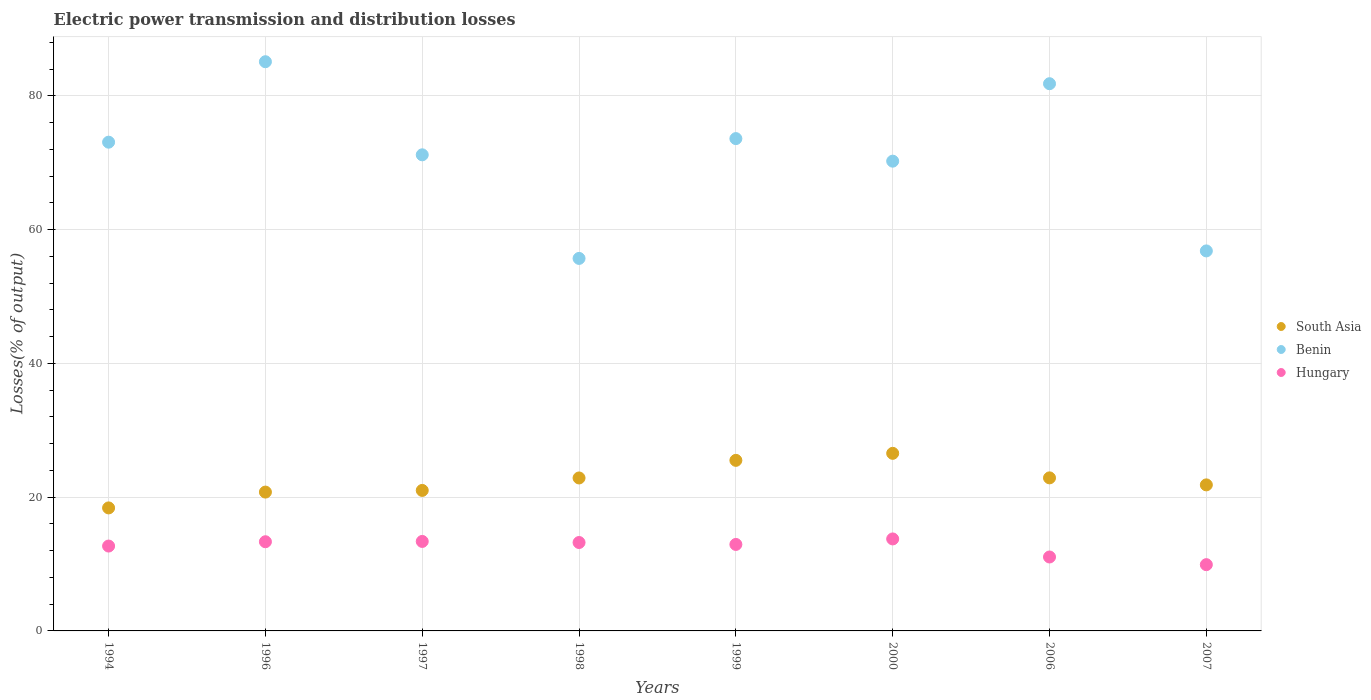How many different coloured dotlines are there?
Make the answer very short. 3. Is the number of dotlines equal to the number of legend labels?
Make the answer very short. Yes. What is the electric power transmission and distribution losses in Benin in 2006?
Give a very brief answer. 81.82. Across all years, what is the maximum electric power transmission and distribution losses in Hungary?
Your response must be concise. 13.75. Across all years, what is the minimum electric power transmission and distribution losses in Hungary?
Your answer should be very brief. 9.91. What is the total electric power transmission and distribution losses in Hungary in the graph?
Offer a very short reply. 100.27. What is the difference between the electric power transmission and distribution losses in South Asia in 1996 and that in 2000?
Provide a succinct answer. -5.79. What is the difference between the electric power transmission and distribution losses in South Asia in 1998 and the electric power transmission and distribution losses in Hungary in 1997?
Make the answer very short. 9.49. What is the average electric power transmission and distribution losses in Benin per year?
Offer a terse response. 70.94. In the year 2007, what is the difference between the electric power transmission and distribution losses in Benin and electric power transmission and distribution losses in South Asia?
Your response must be concise. 34.98. In how many years, is the electric power transmission and distribution losses in Hungary greater than 76 %?
Offer a terse response. 0. What is the ratio of the electric power transmission and distribution losses in South Asia in 1996 to that in 1999?
Give a very brief answer. 0.81. What is the difference between the highest and the second highest electric power transmission and distribution losses in Hungary?
Give a very brief answer. 0.37. What is the difference between the highest and the lowest electric power transmission and distribution losses in South Asia?
Ensure brevity in your answer.  8.16. Is the sum of the electric power transmission and distribution losses in South Asia in 2006 and 2007 greater than the maximum electric power transmission and distribution losses in Hungary across all years?
Make the answer very short. Yes. Is it the case that in every year, the sum of the electric power transmission and distribution losses in Hungary and electric power transmission and distribution losses in South Asia  is greater than the electric power transmission and distribution losses in Benin?
Provide a succinct answer. No. Is the electric power transmission and distribution losses in South Asia strictly greater than the electric power transmission and distribution losses in Hungary over the years?
Provide a succinct answer. Yes. Is the electric power transmission and distribution losses in Benin strictly less than the electric power transmission and distribution losses in South Asia over the years?
Your answer should be compact. No. How many dotlines are there?
Provide a short and direct response. 3. How many years are there in the graph?
Provide a short and direct response. 8. What is the difference between two consecutive major ticks on the Y-axis?
Make the answer very short. 20. Are the values on the major ticks of Y-axis written in scientific E-notation?
Ensure brevity in your answer.  No. Does the graph contain grids?
Offer a terse response. Yes. How are the legend labels stacked?
Your response must be concise. Vertical. What is the title of the graph?
Your answer should be very brief. Electric power transmission and distribution losses. Does "Guam" appear as one of the legend labels in the graph?
Offer a very short reply. No. What is the label or title of the X-axis?
Offer a very short reply. Years. What is the label or title of the Y-axis?
Provide a short and direct response. Losses(% of output). What is the Losses(% of output) of South Asia in 1994?
Your answer should be very brief. 18.39. What is the Losses(% of output) of Benin in 1994?
Provide a short and direct response. 73.08. What is the Losses(% of output) of Hungary in 1994?
Keep it short and to the point. 12.69. What is the Losses(% of output) of South Asia in 1996?
Your response must be concise. 20.76. What is the Losses(% of output) of Benin in 1996?
Make the answer very short. 85.11. What is the Losses(% of output) of Hungary in 1996?
Your response must be concise. 13.33. What is the Losses(% of output) in South Asia in 1997?
Your response must be concise. 21.01. What is the Losses(% of output) in Benin in 1997?
Provide a succinct answer. 71.19. What is the Losses(% of output) in Hungary in 1997?
Provide a short and direct response. 13.38. What is the Losses(% of output) in South Asia in 1998?
Give a very brief answer. 22.87. What is the Losses(% of output) of Benin in 1998?
Your answer should be compact. 55.7. What is the Losses(% of output) in Hungary in 1998?
Your answer should be compact. 13.22. What is the Losses(% of output) of South Asia in 1999?
Provide a short and direct response. 25.5. What is the Losses(% of output) of Benin in 1999?
Make the answer very short. 73.61. What is the Losses(% of output) in Hungary in 1999?
Provide a short and direct response. 12.93. What is the Losses(% of output) of South Asia in 2000?
Your response must be concise. 26.55. What is the Losses(% of output) in Benin in 2000?
Give a very brief answer. 70.24. What is the Losses(% of output) in Hungary in 2000?
Give a very brief answer. 13.75. What is the Losses(% of output) in South Asia in 2006?
Offer a very short reply. 22.88. What is the Losses(% of output) of Benin in 2006?
Your answer should be very brief. 81.82. What is the Losses(% of output) of Hungary in 2006?
Provide a succinct answer. 11.05. What is the Losses(% of output) of South Asia in 2007?
Ensure brevity in your answer.  21.84. What is the Losses(% of output) of Benin in 2007?
Offer a very short reply. 56.82. What is the Losses(% of output) of Hungary in 2007?
Ensure brevity in your answer.  9.91. Across all years, what is the maximum Losses(% of output) of South Asia?
Give a very brief answer. 26.55. Across all years, what is the maximum Losses(% of output) of Benin?
Give a very brief answer. 85.11. Across all years, what is the maximum Losses(% of output) in Hungary?
Provide a succinct answer. 13.75. Across all years, what is the minimum Losses(% of output) of South Asia?
Give a very brief answer. 18.39. Across all years, what is the minimum Losses(% of output) of Benin?
Provide a short and direct response. 55.7. Across all years, what is the minimum Losses(% of output) of Hungary?
Ensure brevity in your answer.  9.91. What is the total Losses(% of output) in South Asia in the graph?
Ensure brevity in your answer.  179.81. What is the total Losses(% of output) of Benin in the graph?
Ensure brevity in your answer.  567.55. What is the total Losses(% of output) in Hungary in the graph?
Provide a succinct answer. 100.27. What is the difference between the Losses(% of output) in South Asia in 1994 and that in 1996?
Your answer should be very brief. -2.37. What is the difference between the Losses(% of output) in Benin in 1994 and that in 1996?
Provide a short and direct response. -12.03. What is the difference between the Losses(% of output) in Hungary in 1994 and that in 1996?
Your answer should be compact. -0.64. What is the difference between the Losses(% of output) of South Asia in 1994 and that in 1997?
Your answer should be compact. -2.62. What is the difference between the Losses(% of output) in Benin in 1994 and that in 1997?
Your answer should be very brief. 1.89. What is the difference between the Losses(% of output) of Hungary in 1994 and that in 1997?
Make the answer very short. -0.69. What is the difference between the Losses(% of output) in South Asia in 1994 and that in 1998?
Give a very brief answer. -4.48. What is the difference between the Losses(% of output) of Benin in 1994 and that in 1998?
Your answer should be compact. 17.38. What is the difference between the Losses(% of output) of Hungary in 1994 and that in 1998?
Give a very brief answer. -0.53. What is the difference between the Losses(% of output) of South Asia in 1994 and that in 1999?
Your answer should be very brief. -7.11. What is the difference between the Losses(% of output) in Benin in 1994 and that in 1999?
Give a very brief answer. -0.53. What is the difference between the Losses(% of output) in Hungary in 1994 and that in 1999?
Your answer should be very brief. -0.24. What is the difference between the Losses(% of output) of South Asia in 1994 and that in 2000?
Ensure brevity in your answer.  -8.16. What is the difference between the Losses(% of output) in Benin in 1994 and that in 2000?
Your answer should be very brief. 2.84. What is the difference between the Losses(% of output) of Hungary in 1994 and that in 2000?
Ensure brevity in your answer.  -1.06. What is the difference between the Losses(% of output) of South Asia in 1994 and that in 2006?
Your response must be concise. -4.49. What is the difference between the Losses(% of output) of Benin in 1994 and that in 2006?
Provide a short and direct response. -8.74. What is the difference between the Losses(% of output) of Hungary in 1994 and that in 2006?
Ensure brevity in your answer.  1.64. What is the difference between the Losses(% of output) in South Asia in 1994 and that in 2007?
Offer a terse response. -3.44. What is the difference between the Losses(% of output) in Benin in 1994 and that in 2007?
Provide a succinct answer. 16.26. What is the difference between the Losses(% of output) in Hungary in 1994 and that in 2007?
Your answer should be compact. 2.78. What is the difference between the Losses(% of output) in South Asia in 1996 and that in 1997?
Offer a terse response. -0.25. What is the difference between the Losses(% of output) in Benin in 1996 and that in 1997?
Provide a succinct answer. 13.92. What is the difference between the Losses(% of output) in Hungary in 1996 and that in 1997?
Make the answer very short. -0.05. What is the difference between the Losses(% of output) of South Asia in 1996 and that in 1998?
Your answer should be compact. -2.11. What is the difference between the Losses(% of output) of Benin in 1996 and that in 1998?
Your response must be concise. 29.41. What is the difference between the Losses(% of output) of Hungary in 1996 and that in 1998?
Provide a succinct answer. 0.12. What is the difference between the Losses(% of output) of South Asia in 1996 and that in 1999?
Your response must be concise. -4.74. What is the difference between the Losses(% of output) in Benin in 1996 and that in 1999?
Offer a terse response. 11.5. What is the difference between the Losses(% of output) in Hungary in 1996 and that in 1999?
Keep it short and to the point. 0.4. What is the difference between the Losses(% of output) of South Asia in 1996 and that in 2000?
Ensure brevity in your answer.  -5.79. What is the difference between the Losses(% of output) in Benin in 1996 and that in 2000?
Keep it short and to the point. 14.87. What is the difference between the Losses(% of output) in Hungary in 1996 and that in 2000?
Provide a short and direct response. -0.42. What is the difference between the Losses(% of output) of South Asia in 1996 and that in 2006?
Your answer should be compact. -2.12. What is the difference between the Losses(% of output) in Benin in 1996 and that in 2006?
Ensure brevity in your answer.  3.29. What is the difference between the Losses(% of output) in Hungary in 1996 and that in 2006?
Offer a terse response. 2.28. What is the difference between the Losses(% of output) of South Asia in 1996 and that in 2007?
Offer a very short reply. -1.08. What is the difference between the Losses(% of output) of Benin in 1996 and that in 2007?
Make the answer very short. 28.29. What is the difference between the Losses(% of output) of Hungary in 1996 and that in 2007?
Ensure brevity in your answer.  3.43. What is the difference between the Losses(% of output) in South Asia in 1997 and that in 1998?
Ensure brevity in your answer.  -1.86. What is the difference between the Losses(% of output) of Benin in 1997 and that in 1998?
Offer a very short reply. 15.49. What is the difference between the Losses(% of output) of Hungary in 1997 and that in 1998?
Provide a succinct answer. 0.16. What is the difference between the Losses(% of output) of South Asia in 1997 and that in 1999?
Provide a short and direct response. -4.5. What is the difference between the Losses(% of output) of Benin in 1997 and that in 1999?
Give a very brief answer. -2.42. What is the difference between the Losses(% of output) of Hungary in 1997 and that in 1999?
Provide a succinct answer. 0.45. What is the difference between the Losses(% of output) in South Asia in 1997 and that in 2000?
Ensure brevity in your answer.  -5.54. What is the difference between the Losses(% of output) in Benin in 1997 and that in 2000?
Ensure brevity in your answer.  0.95. What is the difference between the Losses(% of output) of Hungary in 1997 and that in 2000?
Make the answer very short. -0.37. What is the difference between the Losses(% of output) of South Asia in 1997 and that in 2006?
Your answer should be very brief. -1.88. What is the difference between the Losses(% of output) of Benin in 1997 and that in 2006?
Provide a succinct answer. -10.63. What is the difference between the Losses(% of output) in Hungary in 1997 and that in 2006?
Give a very brief answer. 2.33. What is the difference between the Losses(% of output) in South Asia in 1997 and that in 2007?
Provide a succinct answer. -0.83. What is the difference between the Losses(% of output) of Benin in 1997 and that in 2007?
Your answer should be very brief. 14.37. What is the difference between the Losses(% of output) of Hungary in 1997 and that in 2007?
Offer a very short reply. 3.47. What is the difference between the Losses(% of output) of South Asia in 1998 and that in 1999?
Provide a short and direct response. -2.63. What is the difference between the Losses(% of output) of Benin in 1998 and that in 1999?
Offer a very short reply. -17.91. What is the difference between the Losses(% of output) in Hungary in 1998 and that in 1999?
Provide a short and direct response. 0.29. What is the difference between the Losses(% of output) of South Asia in 1998 and that in 2000?
Provide a succinct answer. -3.68. What is the difference between the Losses(% of output) of Benin in 1998 and that in 2000?
Your response must be concise. -14.54. What is the difference between the Losses(% of output) in Hungary in 1998 and that in 2000?
Your answer should be compact. -0.53. What is the difference between the Losses(% of output) in South Asia in 1998 and that in 2006?
Offer a very short reply. -0.01. What is the difference between the Losses(% of output) in Benin in 1998 and that in 2006?
Offer a very short reply. -26.12. What is the difference between the Losses(% of output) of Hungary in 1998 and that in 2006?
Make the answer very short. 2.16. What is the difference between the Losses(% of output) in South Asia in 1998 and that in 2007?
Your answer should be compact. 1.04. What is the difference between the Losses(% of output) in Benin in 1998 and that in 2007?
Your response must be concise. -1.12. What is the difference between the Losses(% of output) of Hungary in 1998 and that in 2007?
Give a very brief answer. 3.31. What is the difference between the Losses(% of output) in South Asia in 1999 and that in 2000?
Your answer should be compact. -1.05. What is the difference between the Losses(% of output) in Benin in 1999 and that in 2000?
Ensure brevity in your answer.  3.37. What is the difference between the Losses(% of output) in Hungary in 1999 and that in 2000?
Keep it short and to the point. -0.82. What is the difference between the Losses(% of output) in South Asia in 1999 and that in 2006?
Provide a succinct answer. 2.62. What is the difference between the Losses(% of output) of Benin in 1999 and that in 2006?
Provide a short and direct response. -8.21. What is the difference between the Losses(% of output) of Hungary in 1999 and that in 2006?
Offer a terse response. 1.88. What is the difference between the Losses(% of output) of South Asia in 1999 and that in 2007?
Your response must be concise. 3.67. What is the difference between the Losses(% of output) of Benin in 1999 and that in 2007?
Make the answer very short. 16.79. What is the difference between the Losses(% of output) of Hungary in 1999 and that in 2007?
Keep it short and to the point. 3.02. What is the difference between the Losses(% of output) of South Asia in 2000 and that in 2006?
Your response must be concise. 3.67. What is the difference between the Losses(% of output) in Benin in 2000 and that in 2006?
Offer a terse response. -11.58. What is the difference between the Losses(% of output) of Hungary in 2000 and that in 2006?
Offer a very short reply. 2.7. What is the difference between the Losses(% of output) in South Asia in 2000 and that in 2007?
Give a very brief answer. 4.72. What is the difference between the Losses(% of output) of Benin in 2000 and that in 2007?
Ensure brevity in your answer.  13.42. What is the difference between the Losses(% of output) in Hungary in 2000 and that in 2007?
Offer a terse response. 3.85. What is the difference between the Losses(% of output) in South Asia in 2006 and that in 2007?
Keep it short and to the point. 1.05. What is the difference between the Losses(% of output) of Hungary in 2006 and that in 2007?
Make the answer very short. 1.15. What is the difference between the Losses(% of output) in South Asia in 1994 and the Losses(% of output) in Benin in 1996?
Provide a succinct answer. -66.71. What is the difference between the Losses(% of output) in South Asia in 1994 and the Losses(% of output) in Hungary in 1996?
Offer a very short reply. 5.06. What is the difference between the Losses(% of output) of Benin in 1994 and the Losses(% of output) of Hungary in 1996?
Offer a terse response. 59.74. What is the difference between the Losses(% of output) in South Asia in 1994 and the Losses(% of output) in Benin in 1997?
Provide a short and direct response. -52.79. What is the difference between the Losses(% of output) in South Asia in 1994 and the Losses(% of output) in Hungary in 1997?
Ensure brevity in your answer.  5.01. What is the difference between the Losses(% of output) of Benin in 1994 and the Losses(% of output) of Hungary in 1997?
Make the answer very short. 59.7. What is the difference between the Losses(% of output) of South Asia in 1994 and the Losses(% of output) of Benin in 1998?
Ensure brevity in your answer.  -37.3. What is the difference between the Losses(% of output) in South Asia in 1994 and the Losses(% of output) in Hungary in 1998?
Your answer should be very brief. 5.17. What is the difference between the Losses(% of output) in Benin in 1994 and the Losses(% of output) in Hungary in 1998?
Offer a terse response. 59.86. What is the difference between the Losses(% of output) of South Asia in 1994 and the Losses(% of output) of Benin in 1999?
Provide a short and direct response. -55.22. What is the difference between the Losses(% of output) in South Asia in 1994 and the Losses(% of output) in Hungary in 1999?
Your response must be concise. 5.46. What is the difference between the Losses(% of output) of Benin in 1994 and the Losses(% of output) of Hungary in 1999?
Your response must be concise. 60.15. What is the difference between the Losses(% of output) in South Asia in 1994 and the Losses(% of output) in Benin in 2000?
Offer a terse response. -51.85. What is the difference between the Losses(% of output) of South Asia in 1994 and the Losses(% of output) of Hungary in 2000?
Provide a short and direct response. 4.64. What is the difference between the Losses(% of output) of Benin in 1994 and the Losses(% of output) of Hungary in 2000?
Provide a succinct answer. 59.32. What is the difference between the Losses(% of output) in South Asia in 1994 and the Losses(% of output) in Benin in 2006?
Keep it short and to the point. -63.43. What is the difference between the Losses(% of output) in South Asia in 1994 and the Losses(% of output) in Hungary in 2006?
Provide a short and direct response. 7.34. What is the difference between the Losses(% of output) in Benin in 1994 and the Losses(% of output) in Hungary in 2006?
Your answer should be very brief. 62.02. What is the difference between the Losses(% of output) of South Asia in 1994 and the Losses(% of output) of Benin in 2007?
Ensure brevity in your answer.  -38.43. What is the difference between the Losses(% of output) of South Asia in 1994 and the Losses(% of output) of Hungary in 2007?
Your answer should be very brief. 8.48. What is the difference between the Losses(% of output) in Benin in 1994 and the Losses(% of output) in Hungary in 2007?
Provide a short and direct response. 63.17. What is the difference between the Losses(% of output) in South Asia in 1996 and the Losses(% of output) in Benin in 1997?
Give a very brief answer. -50.43. What is the difference between the Losses(% of output) of South Asia in 1996 and the Losses(% of output) of Hungary in 1997?
Offer a terse response. 7.38. What is the difference between the Losses(% of output) in Benin in 1996 and the Losses(% of output) in Hungary in 1997?
Offer a very short reply. 71.73. What is the difference between the Losses(% of output) in South Asia in 1996 and the Losses(% of output) in Benin in 1998?
Your answer should be compact. -34.94. What is the difference between the Losses(% of output) of South Asia in 1996 and the Losses(% of output) of Hungary in 1998?
Offer a terse response. 7.54. What is the difference between the Losses(% of output) in Benin in 1996 and the Losses(% of output) in Hungary in 1998?
Ensure brevity in your answer.  71.89. What is the difference between the Losses(% of output) of South Asia in 1996 and the Losses(% of output) of Benin in 1999?
Provide a short and direct response. -52.85. What is the difference between the Losses(% of output) of South Asia in 1996 and the Losses(% of output) of Hungary in 1999?
Offer a very short reply. 7.83. What is the difference between the Losses(% of output) of Benin in 1996 and the Losses(% of output) of Hungary in 1999?
Keep it short and to the point. 72.18. What is the difference between the Losses(% of output) of South Asia in 1996 and the Losses(% of output) of Benin in 2000?
Offer a very short reply. -49.48. What is the difference between the Losses(% of output) of South Asia in 1996 and the Losses(% of output) of Hungary in 2000?
Give a very brief answer. 7.01. What is the difference between the Losses(% of output) in Benin in 1996 and the Losses(% of output) in Hungary in 2000?
Offer a very short reply. 71.35. What is the difference between the Losses(% of output) in South Asia in 1996 and the Losses(% of output) in Benin in 2006?
Ensure brevity in your answer.  -61.06. What is the difference between the Losses(% of output) in South Asia in 1996 and the Losses(% of output) in Hungary in 2006?
Offer a terse response. 9.71. What is the difference between the Losses(% of output) in Benin in 1996 and the Losses(% of output) in Hungary in 2006?
Make the answer very short. 74.05. What is the difference between the Losses(% of output) of South Asia in 1996 and the Losses(% of output) of Benin in 2007?
Your response must be concise. -36.06. What is the difference between the Losses(% of output) of South Asia in 1996 and the Losses(% of output) of Hungary in 2007?
Make the answer very short. 10.85. What is the difference between the Losses(% of output) of Benin in 1996 and the Losses(% of output) of Hungary in 2007?
Offer a very short reply. 75.2. What is the difference between the Losses(% of output) of South Asia in 1997 and the Losses(% of output) of Benin in 1998?
Give a very brief answer. -34.69. What is the difference between the Losses(% of output) in South Asia in 1997 and the Losses(% of output) in Hungary in 1998?
Provide a short and direct response. 7.79. What is the difference between the Losses(% of output) of Benin in 1997 and the Losses(% of output) of Hungary in 1998?
Ensure brevity in your answer.  57.97. What is the difference between the Losses(% of output) of South Asia in 1997 and the Losses(% of output) of Benin in 1999?
Offer a very short reply. -52.6. What is the difference between the Losses(% of output) in South Asia in 1997 and the Losses(% of output) in Hungary in 1999?
Give a very brief answer. 8.08. What is the difference between the Losses(% of output) in Benin in 1997 and the Losses(% of output) in Hungary in 1999?
Your response must be concise. 58.26. What is the difference between the Losses(% of output) of South Asia in 1997 and the Losses(% of output) of Benin in 2000?
Ensure brevity in your answer.  -49.23. What is the difference between the Losses(% of output) of South Asia in 1997 and the Losses(% of output) of Hungary in 2000?
Provide a short and direct response. 7.25. What is the difference between the Losses(% of output) in Benin in 1997 and the Losses(% of output) in Hungary in 2000?
Keep it short and to the point. 57.43. What is the difference between the Losses(% of output) of South Asia in 1997 and the Losses(% of output) of Benin in 2006?
Provide a succinct answer. -60.81. What is the difference between the Losses(% of output) in South Asia in 1997 and the Losses(% of output) in Hungary in 2006?
Your answer should be compact. 9.95. What is the difference between the Losses(% of output) of Benin in 1997 and the Losses(% of output) of Hungary in 2006?
Make the answer very short. 60.13. What is the difference between the Losses(% of output) of South Asia in 1997 and the Losses(% of output) of Benin in 2007?
Offer a terse response. -35.81. What is the difference between the Losses(% of output) in South Asia in 1997 and the Losses(% of output) in Hungary in 2007?
Your answer should be very brief. 11.1. What is the difference between the Losses(% of output) of Benin in 1997 and the Losses(% of output) of Hungary in 2007?
Your answer should be compact. 61.28. What is the difference between the Losses(% of output) in South Asia in 1998 and the Losses(% of output) in Benin in 1999?
Offer a very short reply. -50.74. What is the difference between the Losses(% of output) of South Asia in 1998 and the Losses(% of output) of Hungary in 1999?
Your answer should be compact. 9.94. What is the difference between the Losses(% of output) of Benin in 1998 and the Losses(% of output) of Hungary in 1999?
Your answer should be very brief. 42.77. What is the difference between the Losses(% of output) in South Asia in 1998 and the Losses(% of output) in Benin in 2000?
Ensure brevity in your answer.  -47.37. What is the difference between the Losses(% of output) of South Asia in 1998 and the Losses(% of output) of Hungary in 2000?
Provide a short and direct response. 9.12. What is the difference between the Losses(% of output) of Benin in 1998 and the Losses(% of output) of Hungary in 2000?
Provide a short and direct response. 41.94. What is the difference between the Losses(% of output) in South Asia in 1998 and the Losses(% of output) in Benin in 2006?
Keep it short and to the point. -58.95. What is the difference between the Losses(% of output) of South Asia in 1998 and the Losses(% of output) of Hungary in 2006?
Your answer should be compact. 11.82. What is the difference between the Losses(% of output) in Benin in 1998 and the Losses(% of output) in Hungary in 2006?
Your answer should be compact. 44.64. What is the difference between the Losses(% of output) of South Asia in 1998 and the Losses(% of output) of Benin in 2007?
Your answer should be very brief. -33.95. What is the difference between the Losses(% of output) of South Asia in 1998 and the Losses(% of output) of Hungary in 2007?
Provide a short and direct response. 12.96. What is the difference between the Losses(% of output) in Benin in 1998 and the Losses(% of output) in Hungary in 2007?
Keep it short and to the point. 45.79. What is the difference between the Losses(% of output) in South Asia in 1999 and the Losses(% of output) in Benin in 2000?
Offer a very short reply. -44.74. What is the difference between the Losses(% of output) of South Asia in 1999 and the Losses(% of output) of Hungary in 2000?
Offer a terse response. 11.75. What is the difference between the Losses(% of output) of Benin in 1999 and the Losses(% of output) of Hungary in 2000?
Provide a succinct answer. 59.86. What is the difference between the Losses(% of output) in South Asia in 1999 and the Losses(% of output) in Benin in 2006?
Your response must be concise. -56.32. What is the difference between the Losses(% of output) of South Asia in 1999 and the Losses(% of output) of Hungary in 2006?
Provide a succinct answer. 14.45. What is the difference between the Losses(% of output) of Benin in 1999 and the Losses(% of output) of Hungary in 2006?
Provide a succinct answer. 62.56. What is the difference between the Losses(% of output) in South Asia in 1999 and the Losses(% of output) in Benin in 2007?
Offer a terse response. -31.32. What is the difference between the Losses(% of output) of South Asia in 1999 and the Losses(% of output) of Hungary in 2007?
Your response must be concise. 15.6. What is the difference between the Losses(% of output) in Benin in 1999 and the Losses(% of output) in Hungary in 2007?
Give a very brief answer. 63.7. What is the difference between the Losses(% of output) in South Asia in 2000 and the Losses(% of output) in Benin in 2006?
Your answer should be very brief. -55.27. What is the difference between the Losses(% of output) of South Asia in 2000 and the Losses(% of output) of Hungary in 2006?
Make the answer very short. 15.5. What is the difference between the Losses(% of output) in Benin in 2000 and the Losses(% of output) in Hungary in 2006?
Your response must be concise. 59.18. What is the difference between the Losses(% of output) in South Asia in 2000 and the Losses(% of output) in Benin in 2007?
Make the answer very short. -30.27. What is the difference between the Losses(% of output) of South Asia in 2000 and the Losses(% of output) of Hungary in 2007?
Your answer should be compact. 16.64. What is the difference between the Losses(% of output) in Benin in 2000 and the Losses(% of output) in Hungary in 2007?
Keep it short and to the point. 60.33. What is the difference between the Losses(% of output) in South Asia in 2006 and the Losses(% of output) in Benin in 2007?
Make the answer very short. -33.93. What is the difference between the Losses(% of output) of South Asia in 2006 and the Losses(% of output) of Hungary in 2007?
Your answer should be very brief. 12.98. What is the difference between the Losses(% of output) of Benin in 2006 and the Losses(% of output) of Hungary in 2007?
Offer a terse response. 71.91. What is the average Losses(% of output) of South Asia per year?
Offer a terse response. 22.48. What is the average Losses(% of output) of Benin per year?
Ensure brevity in your answer.  70.94. What is the average Losses(% of output) of Hungary per year?
Your answer should be very brief. 12.53. In the year 1994, what is the difference between the Losses(% of output) of South Asia and Losses(% of output) of Benin?
Provide a succinct answer. -54.68. In the year 1994, what is the difference between the Losses(% of output) of South Asia and Losses(% of output) of Hungary?
Your answer should be very brief. 5.7. In the year 1994, what is the difference between the Losses(% of output) in Benin and Losses(% of output) in Hungary?
Keep it short and to the point. 60.39. In the year 1996, what is the difference between the Losses(% of output) of South Asia and Losses(% of output) of Benin?
Your response must be concise. -64.35. In the year 1996, what is the difference between the Losses(% of output) of South Asia and Losses(% of output) of Hungary?
Your answer should be compact. 7.43. In the year 1996, what is the difference between the Losses(% of output) of Benin and Losses(% of output) of Hungary?
Offer a very short reply. 71.77. In the year 1997, what is the difference between the Losses(% of output) in South Asia and Losses(% of output) in Benin?
Your answer should be compact. -50.18. In the year 1997, what is the difference between the Losses(% of output) in South Asia and Losses(% of output) in Hungary?
Your answer should be compact. 7.63. In the year 1997, what is the difference between the Losses(% of output) of Benin and Losses(% of output) of Hungary?
Your response must be concise. 57.81. In the year 1998, what is the difference between the Losses(% of output) of South Asia and Losses(% of output) of Benin?
Provide a short and direct response. -32.83. In the year 1998, what is the difference between the Losses(% of output) of South Asia and Losses(% of output) of Hungary?
Provide a short and direct response. 9.65. In the year 1998, what is the difference between the Losses(% of output) of Benin and Losses(% of output) of Hungary?
Make the answer very short. 42.48. In the year 1999, what is the difference between the Losses(% of output) in South Asia and Losses(% of output) in Benin?
Make the answer very short. -48.11. In the year 1999, what is the difference between the Losses(% of output) in South Asia and Losses(% of output) in Hungary?
Your answer should be very brief. 12.57. In the year 1999, what is the difference between the Losses(% of output) of Benin and Losses(% of output) of Hungary?
Ensure brevity in your answer.  60.68. In the year 2000, what is the difference between the Losses(% of output) of South Asia and Losses(% of output) of Benin?
Offer a terse response. -43.69. In the year 2000, what is the difference between the Losses(% of output) in South Asia and Losses(% of output) in Hungary?
Your response must be concise. 12.8. In the year 2000, what is the difference between the Losses(% of output) in Benin and Losses(% of output) in Hungary?
Your response must be concise. 56.48. In the year 2006, what is the difference between the Losses(% of output) in South Asia and Losses(% of output) in Benin?
Offer a terse response. -58.93. In the year 2006, what is the difference between the Losses(% of output) in South Asia and Losses(% of output) in Hungary?
Ensure brevity in your answer.  11.83. In the year 2006, what is the difference between the Losses(% of output) in Benin and Losses(% of output) in Hungary?
Your response must be concise. 70.76. In the year 2007, what is the difference between the Losses(% of output) of South Asia and Losses(% of output) of Benin?
Your response must be concise. -34.98. In the year 2007, what is the difference between the Losses(% of output) in South Asia and Losses(% of output) in Hungary?
Your response must be concise. 11.93. In the year 2007, what is the difference between the Losses(% of output) in Benin and Losses(% of output) in Hungary?
Keep it short and to the point. 46.91. What is the ratio of the Losses(% of output) in South Asia in 1994 to that in 1996?
Ensure brevity in your answer.  0.89. What is the ratio of the Losses(% of output) in Benin in 1994 to that in 1996?
Offer a very short reply. 0.86. What is the ratio of the Losses(% of output) in Hungary in 1994 to that in 1996?
Keep it short and to the point. 0.95. What is the ratio of the Losses(% of output) of South Asia in 1994 to that in 1997?
Give a very brief answer. 0.88. What is the ratio of the Losses(% of output) in Benin in 1994 to that in 1997?
Your response must be concise. 1.03. What is the ratio of the Losses(% of output) of Hungary in 1994 to that in 1997?
Your answer should be compact. 0.95. What is the ratio of the Losses(% of output) of South Asia in 1994 to that in 1998?
Offer a very short reply. 0.8. What is the ratio of the Losses(% of output) in Benin in 1994 to that in 1998?
Offer a very short reply. 1.31. What is the ratio of the Losses(% of output) of Hungary in 1994 to that in 1998?
Keep it short and to the point. 0.96. What is the ratio of the Losses(% of output) in South Asia in 1994 to that in 1999?
Keep it short and to the point. 0.72. What is the ratio of the Losses(% of output) of Hungary in 1994 to that in 1999?
Make the answer very short. 0.98. What is the ratio of the Losses(% of output) in South Asia in 1994 to that in 2000?
Keep it short and to the point. 0.69. What is the ratio of the Losses(% of output) in Benin in 1994 to that in 2000?
Give a very brief answer. 1.04. What is the ratio of the Losses(% of output) of Hungary in 1994 to that in 2000?
Offer a very short reply. 0.92. What is the ratio of the Losses(% of output) of South Asia in 1994 to that in 2006?
Offer a terse response. 0.8. What is the ratio of the Losses(% of output) of Benin in 1994 to that in 2006?
Provide a short and direct response. 0.89. What is the ratio of the Losses(% of output) in Hungary in 1994 to that in 2006?
Offer a very short reply. 1.15. What is the ratio of the Losses(% of output) in South Asia in 1994 to that in 2007?
Your answer should be compact. 0.84. What is the ratio of the Losses(% of output) in Benin in 1994 to that in 2007?
Make the answer very short. 1.29. What is the ratio of the Losses(% of output) in Hungary in 1994 to that in 2007?
Give a very brief answer. 1.28. What is the ratio of the Losses(% of output) of South Asia in 1996 to that in 1997?
Offer a very short reply. 0.99. What is the ratio of the Losses(% of output) of Benin in 1996 to that in 1997?
Your answer should be very brief. 1.2. What is the ratio of the Losses(% of output) in South Asia in 1996 to that in 1998?
Provide a succinct answer. 0.91. What is the ratio of the Losses(% of output) in Benin in 1996 to that in 1998?
Offer a very short reply. 1.53. What is the ratio of the Losses(% of output) in Hungary in 1996 to that in 1998?
Give a very brief answer. 1.01. What is the ratio of the Losses(% of output) in South Asia in 1996 to that in 1999?
Make the answer very short. 0.81. What is the ratio of the Losses(% of output) of Benin in 1996 to that in 1999?
Your response must be concise. 1.16. What is the ratio of the Losses(% of output) in Hungary in 1996 to that in 1999?
Provide a short and direct response. 1.03. What is the ratio of the Losses(% of output) of South Asia in 1996 to that in 2000?
Ensure brevity in your answer.  0.78. What is the ratio of the Losses(% of output) in Benin in 1996 to that in 2000?
Keep it short and to the point. 1.21. What is the ratio of the Losses(% of output) of Hungary in 1996 to that in 2000?
Ensure brevity in your answer.  0.97. What is the ratio of the Losses(% of output) of South Asia in 1996 to that in 2006?
Provide a short and direct response. 0.91. What is the ratio of the Losses(% of output) of Benin in 1996 to that in 2006?
Keep it short and to the point. 1.04. What is the ratio of the Losses(% of output) of Hungary in 1996 to that in 2006?
Your answer should be very brief. 1.21. What is the ratio of the Losses(% of output) of South Asia in 1996 to that in 2007?
Your answer should be compact. 0.95. What is the ratio of the Losses(% of output) in Benin in 1996 to that in 2007?
Ensure brevity in your answer.  1.5. What is the ratio of the Losses(% of output) in Hungary in 1996 to that in 2007?
Provide a succinct answer. 1.35. What is the ratio of the Losses(% of output) in South Asia in 1997 to that in 1998?
Make the answer very short. 0.92. What is the ratio of the Losses(% of output) in Benin in 1997 to that in 1998?
Provide a succinct answer. 1.28. What is the ratio of the Losses(% of output) in Hungary in 1997 to that in 1998?
Offer a very short reply. 1.01. What is the ratio of the Losses(% of output) in South Asia in 1997 to that in 1999?
Ensure brevity in your answer.  0.82. What is the ratio of the Losses(% of output) in Benin in 1997 to that in 1999?
Give a very brief answer. 0.97. What is the ratio of the Losses(% of output) of Hungary in 1997 to that in 1999?
Your answer should be compact. 1.03. What is the ratio of the Losses(% of output) in South Asia in 1997 to that in 2000?
Keep it short and to the point. 0.79. What is the ratio of the Losses(% of output) of Benin in 1997 to that in 2000?
Provide a short and direct response. 1.01. What is the ratio of the Losses(% of output) of Hungary in 1997 to that in 2000?
Provide a short and direct response. 0.97. What is the ratio of the Losses(% of output) of South Asia in 1997 to that in 2006?
Keep it short and to the point. 0.92. What is the ratio of the Losses(% of output) in Benin in 1997 to that in 2006?
Make the answer very short. 0.87. What is the ratio of the Losses(% of output) in Hungary in 1997 to that in 2006?
Provide a succinct answer. 1.21. What is the ratio of the Losses(% of output) in South Asia in 1997 to that in 2007?
Keep it short and to the point. 0.96. What is the ratio of the Losses(% of output) in Benin in 1997 to that in 2007?
Offer a terse response. 1.25. What is the ratio of the Losses(% of output) of Hungary in 1997 to that in 2007?
Your response must be concise. 1.35. What is the ratio of the Losses(% of output) of South Asia in 1998 to that in 1999?
Your answer should be very brief. 0.9. What is the ratio of the Losses(% of output) in Benin in 1998 to that in 1999?
Your answer should be compact. 0.76. What is the ratio of the Losses(% of output) in Hungary in 1998 to that in 1999?
Offer a very short reply. 1.02. What is the ratio of the Losses(% of output) of South Asia in 1998 to that in 2000?
Offer a very short reply. 0.86. What is the ratio of the Losses(% of output) in Benin in 1998 to that in 2000?
Keep it short and to the point. 0.79. What is the ratio of the Losses(% of output) of Hungary in 1998 to that in 2000?
Keep it short and to the point. 0.96. What is the ratio of the Losses(% of output) of Benin in 1998 to that in 2006?
Provide a short and direct response. 0.68. What is the ratio of the Losses(% of output) in Hungary in 1998 to that in 2006?
Your answer should be very brief. 1.2. What is the ratio of the Losses(% of output) of South Asia in 1998 to that in 2007?
Your response must be concise. 1.05. What is the ratio of the Losses(% of output) in Benin in 1998 to that in 2007?
Your response must be concise. 0.98. What is the ratio of the Losses(% of output) in Hungary in 1998 to that in 2007?
Offer a terse response. 1.33. What is the ratio of the Losses(% of output) of South Asia in 1999 to that in 2000?
Keep it short and to the point. 0.96. What is the ratio of the Losses(% of output) of Benin in 1999 to that in 2000?
Ensure brevity in your answer.  1.05. What is the ratio of the Losses(% of output) of Hungary in 1999 to that in 2000?
Your response must be concise. 0.94. What is the ratio of the Losses(% of output) in South Asia in 1999 to that in 2006?
Your answer should be very brief. 1.11. What is the ratio of the Losses(% of output) of Benin in 1999 to that in 2006?
Provide a short and direct response. 0.9. What is the ratio of the Losses(% of output) in Hungary in 1999 to that in 2006?
Ensure brevity in your answer.  1.17. What is the ratio of the Losses(% of output) in South Asia in 1999 to that in 2007?
Your answer should be very brief. 1.17. What is the ratio of the Losses(% of output) in Benin in 1999 to that in 2007?
Ensure brevity in your answer.  1.3. What is the ratio of the Losses(% of output) in Hungary in 1999 to that in 2007?
Your answer should be very brief. 1.31. What is the ratio of the Losses(% of output) of South Asia in 2000 to that in 2006?
Offer a very short reply. 1.16. What is the ratio of the Losses(% of output) of Benin in 2000 to that in 2006?
Give a very brief answer. 0.86. What is the ratio of the Losses(% of output) in Hungary in 2000 to that in 2006?
Your answer should be compact. 1.24. What is the ratio of the Losses(% of output) of South Asia in 2000 to that in 2007?
Make the answer very short. 1.22. What is the ratio of the Losses(% of output) in Benin in 2000 to that in 2007?
Keep it short and to the point. 1.24. What is the ratio of the Losses(% of output) of Hungary in 2000 to that in 2007?
Your answer should be compact. 1.39. What is the ratio of the Losses(% of output) in South Asia in 2006 to that in 2007?
Offer a very short reply. 1.05. What is the ratio of the Losses(% of output) in Benin in 2006 to that in 2007?
Give a very brief answer. 1.44. What is the ratio of the Losses(% of output) in Hungary in 2006 to that in 2007?
Your answer should be very brief. 1.12. What is the difference between the highest and the second highest Losses(% of output) of South Asia?
Your response must be concise. 1.05. What is the difference between the highest and the second highest Losses(% of output) of Benin?
Your response must be concise. 3.29. What is the difference between the highest and the second highest Losses(% of output) of Hungary?
Make the answer very short. 0.37. What is the difference between the highest and the lowest Losses(% of output) of South Asia?
Offer a terse response. 8.16. What is the difference between the highest and the lowest Losses(% of output) of Benin?
Provide a short and direct response. 29.41. What is the difference between the highest and the lowest Losses(% of output) of Hungary?
Keep it short and to the point. 3.85. 